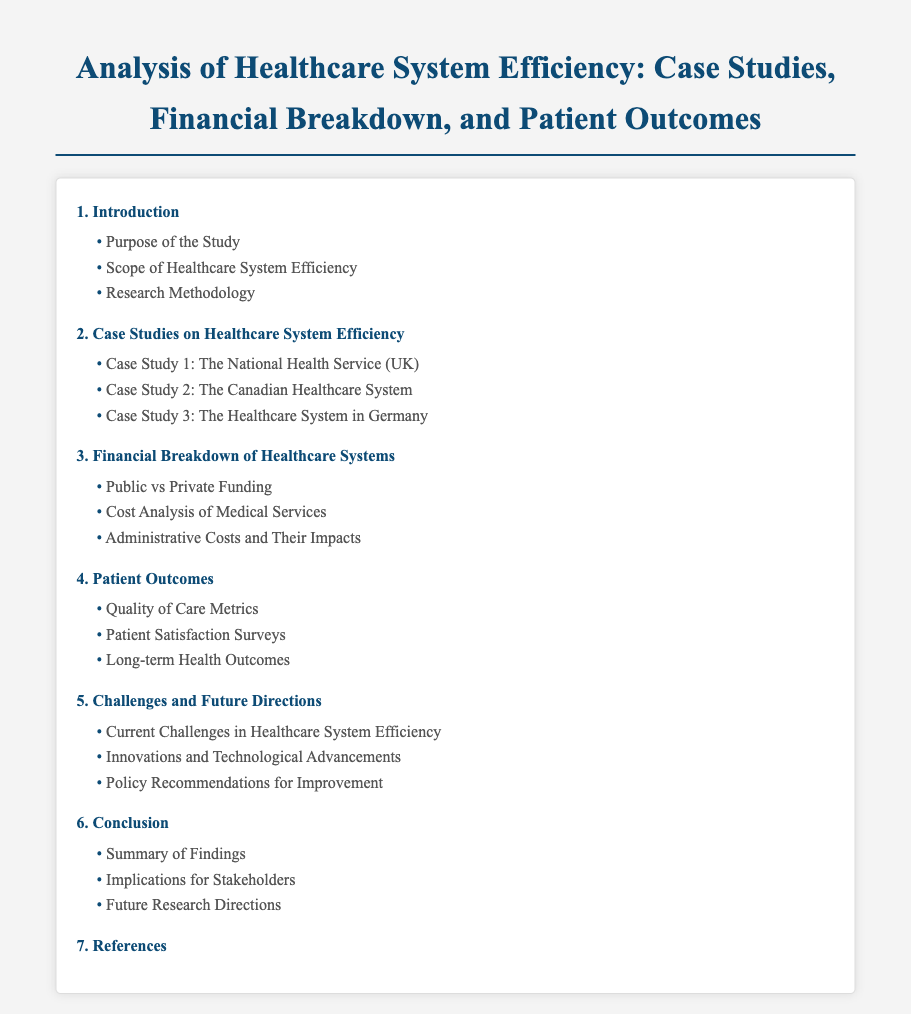What is the title of the document? The title of the document is the main heading present at the top of the rendered document.
Answer: Analysis of Healthcare System Efficiency: Case Studies, Financial Breakdown, and Patient Outcomes How many case studies are included? The number of case studies can be found in the second section of the table of contents.
Answer: 3 What is the first subsection under the "Introduction"? The first subsection is the initial topic discussed in the introduction section.
Answer: Purpose of the Study What is the focus of Section 3? This section specifically deals with the financial aspects of healthcare systems.
Answer: Financial Breakdown of Healthcare Systems What does the final section of the document address? The final section summarizes the findings and discusses implications and directions for future research.
Answer: Conclusion What type of metrics are assessed in Section 4? This section examines specific measurements regarding patient quality of care.
Answer: Quality of Care Metrics What recommendation is made in Section 5? The second subsection discusses possible advancements and suggestions for improvement in healthcare systems.
Answer: Policy Recommendations for Improvement 